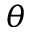<formula> <loc_0><loc_0><loc_500><loc_500>\theta</formula> 